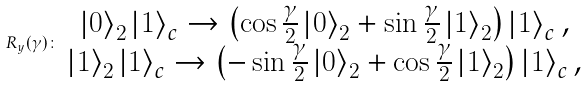Convert formula to latex. <formula><loc_0><loc_0><loc_500><loc_500>R _ { y } ( \gamma ) \colon \begin{array} { c } \left | 0 \right \rangle _ { 2 } \left | 1 \right \rangle _ { c } \rightarrow \left ( \cos \frac { \gamma } { 2 } \left | 0 \right \rangle _ { 2 } + \sin \frac { \gamma } { 2 } \left | 1 \right \rangle _ { 2 } \right ) \left | 1 \right \rangle _ { c } , \\ \left | 1 \right \rangle _ { 2 } \left | 1 \right \rangle _ { c } \rightarrow \left ( - \sin \frac { \gamma } { 2 } \left | 0 \right \rangle _ { 2 } + \cos \frac { \gamma } { 2 } \left | 1 \right \rangle _ { 2 } \right ) \left | 1 \right \rangle _ { c } , \end{array}</formula> 